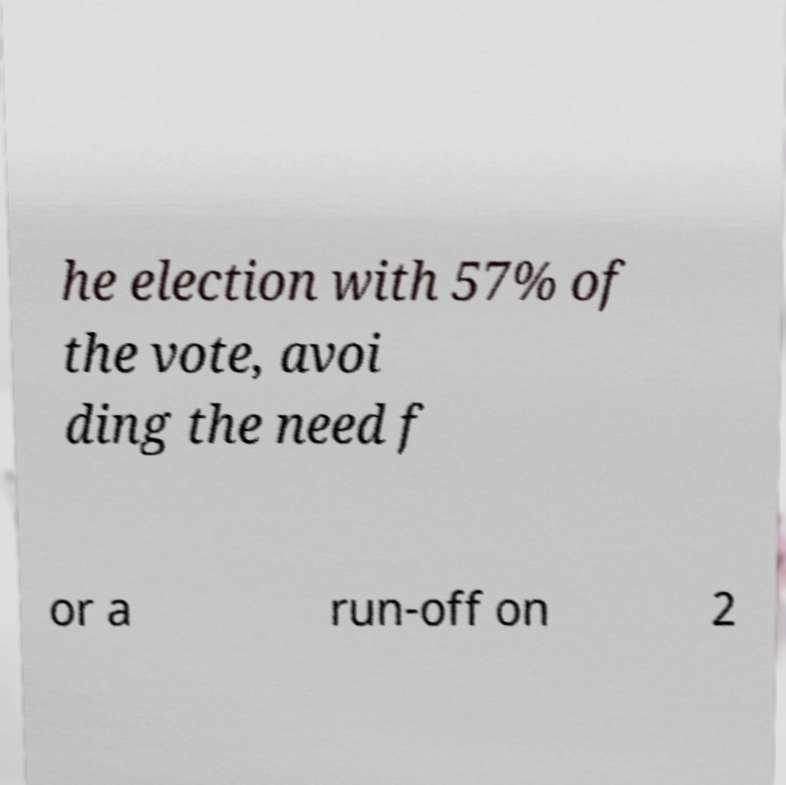What messages or text are displayed in this image? I need them in a readable, typed format. he election with 57% of the vote, avoi ding the need f or a run-off on 2 